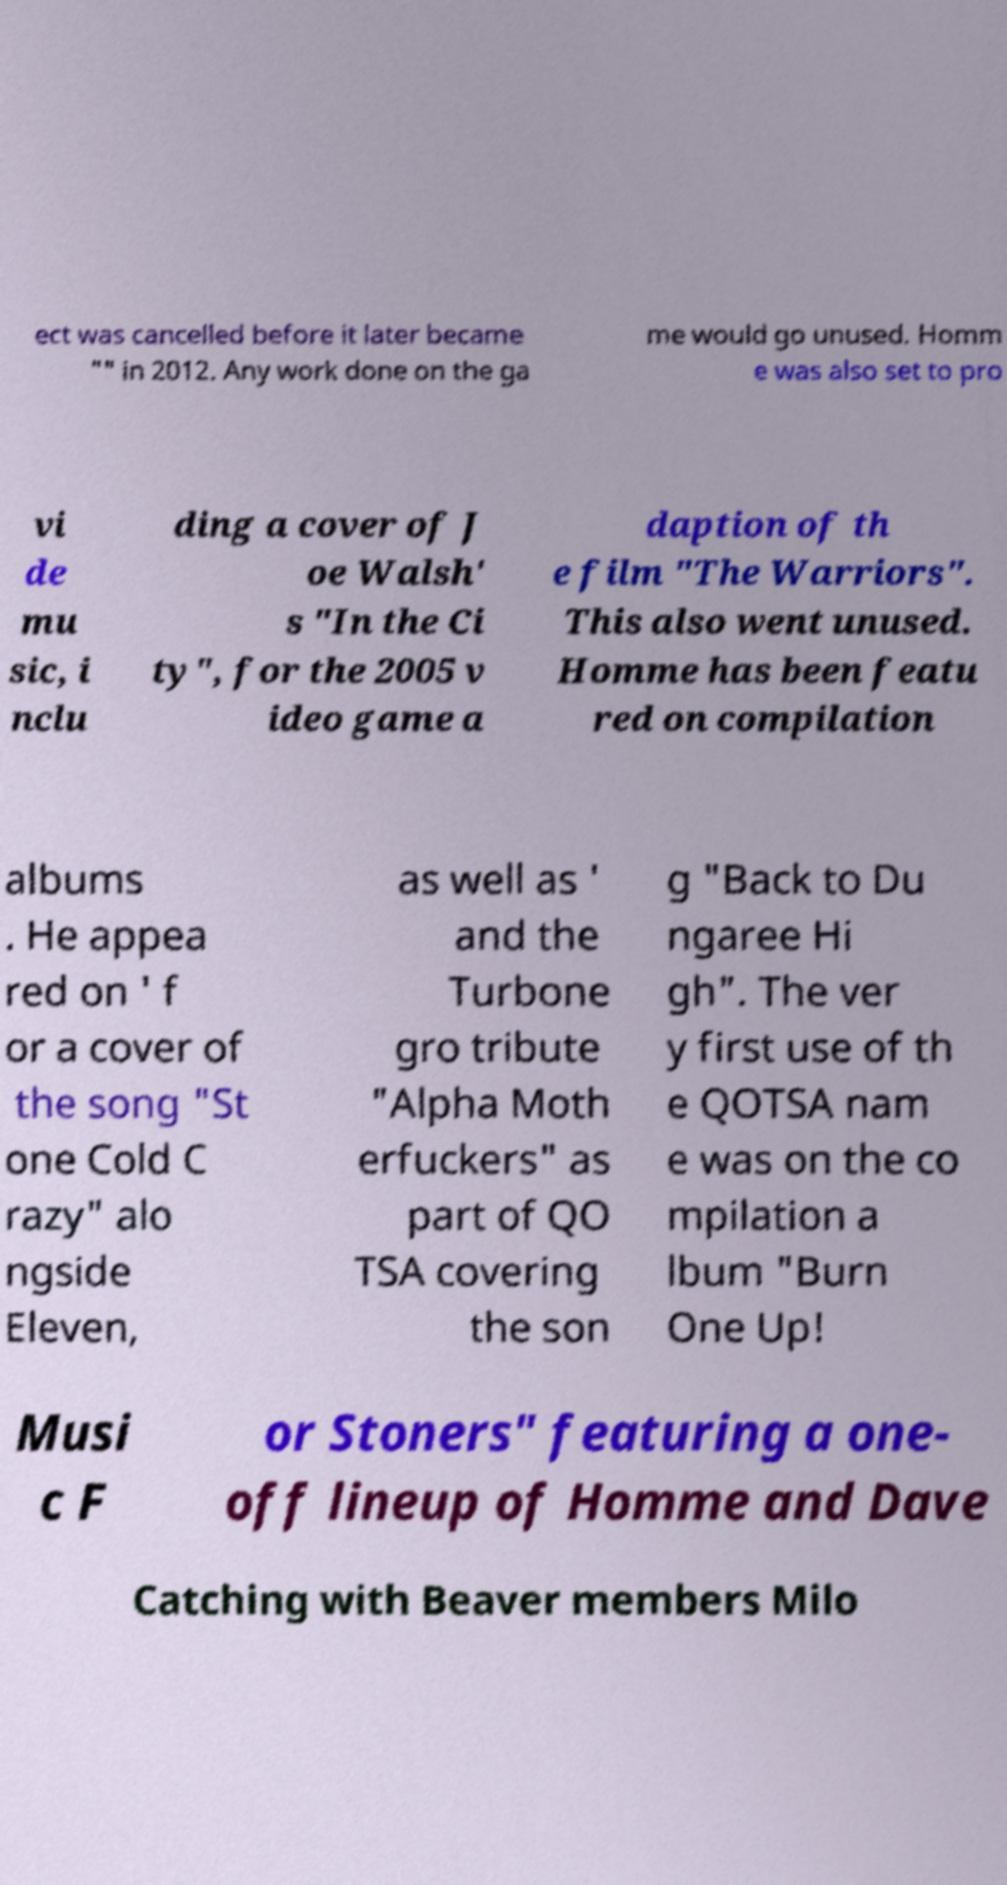Please read and relay the text visible in this image. What does it say? ect was cancelled before it later became "" in 2012. Any work done on the ga me would go unused. Homm e was also set to pro vi de mu sic, i nclu ding a cover of J oe Walsh' s "In the Ci ty", for the 2005 v ideo game a daption of th e film "The Warriors". This also went unused. Homme has been featu red on compilation albums . He appea red on ' f or a cover of the song "St one Cold C razy" alo ngside Eleven, as well as ' and the Turbone gro tribute "Alpha Moth erfuckers" as part of QO TSA covering the son g "Back to Du ngaree Hi gh". The ver y first use of th e QOTSA nam e was on the co mpilation a lbum "Burn One Up! Musi c F or Stoners" featuring a one- off lineup of Homme and Dave Catching with Beaver members Milo 